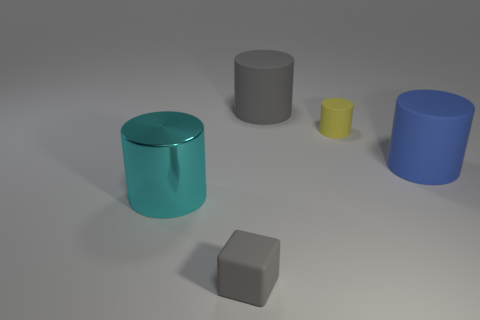Subtract all gray cylinders. How many cylinders are left? 3 Subtract all blue rubber cylinders. How many cylinders are left? 3 Subtract all cylinders. How many objects are left? 1 Subtract 1 cylinders. How many cylinders are left? 3 Subtract all purple balls. How many yellow cylinders are left? 1 Add 3 large gray cylinders. How many large gray cylinders exist? 4 Add 5 big cyan objects. How many objects exist? 10 Subtract 1 cyan cylinders. How many objects are left? 4 Subtract all blue cylinders. Subtract all purple balls. How many cylinders are left? 3 Subtract all large gray metal things. Subtract all large cyan cylinders. How many objects are left? 4 